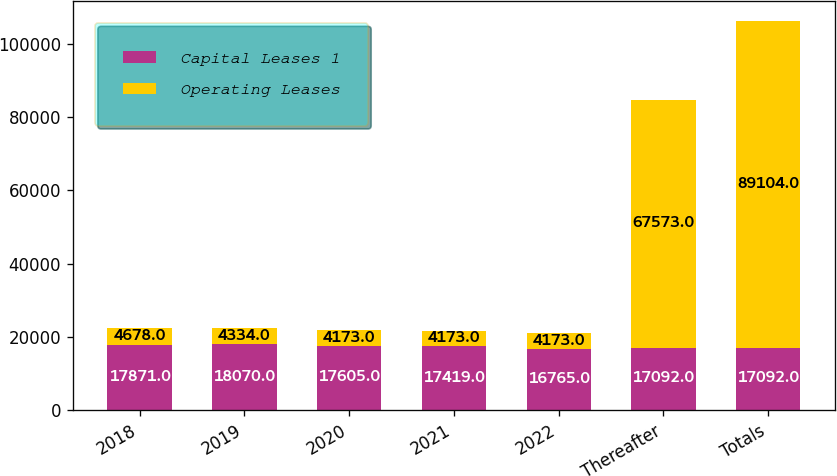Convert chart. <chart><loc_0><loc_0><loc_500><loc_500><stacked_bar_chart><ecel><fcel>2018<fcel>2019<fcel>2020<fcel>2021<fcel>2022<fcel>Thereafter<fcel>Totals<nl><fcel>Capital Leases 1<fcel>17871<fcel>18070<fcel>17605<fcel>17419<fcel>16765<fcel>17092<fcel>17092<nl><fcel>Operating Leases<fcel>4678<fcel>4334<fcel>4173<fcel>4173<fcel>4173<fcel>67573<fcel>89104<nl></chart> 